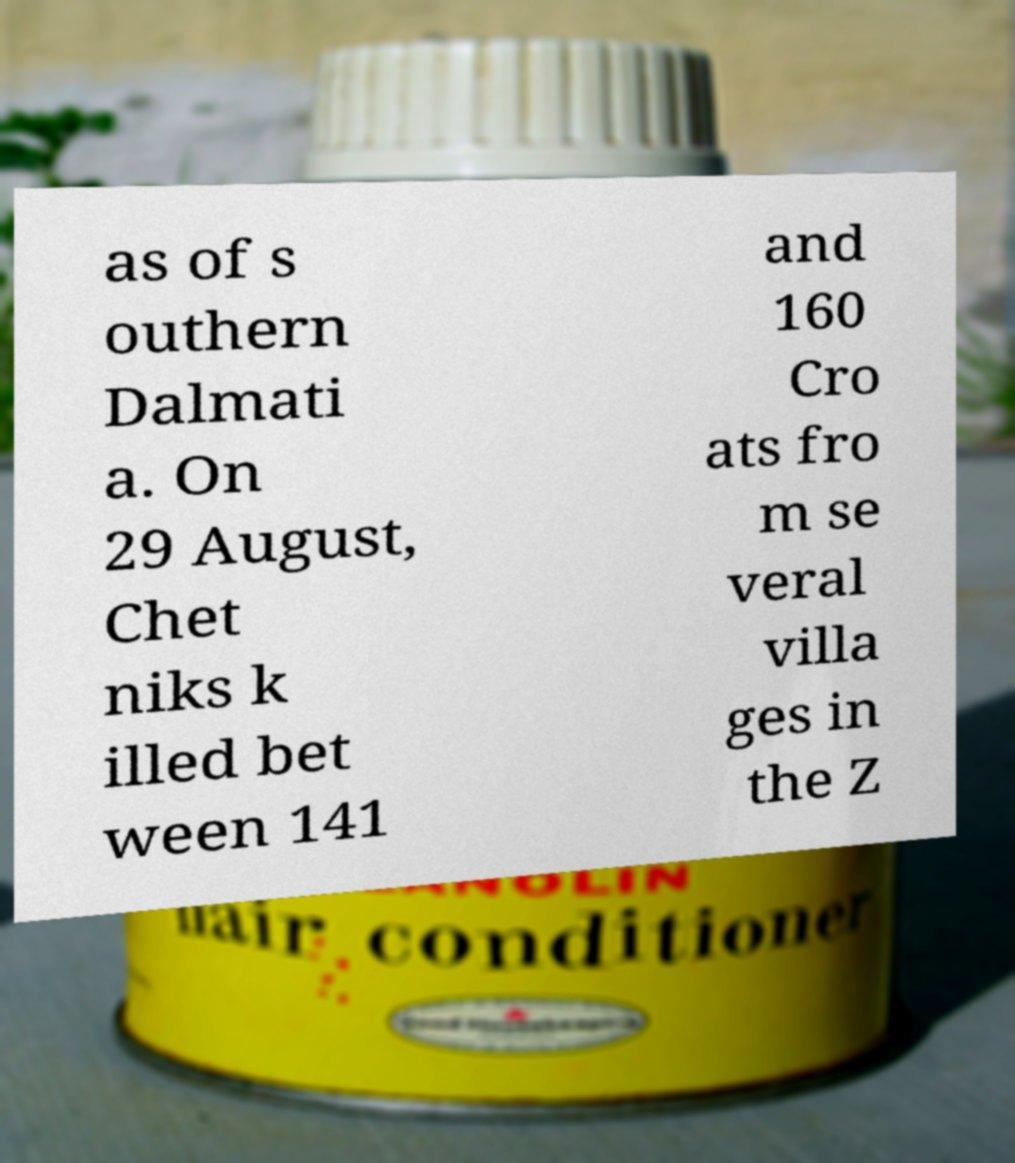Can you accurately transcribe the text from the provided image for me? as of s outhern Dalmati a. On 29 August, Chet niks k illed bet ween 141 and 160 Cro ats fro m se veral villa ges in the Z 